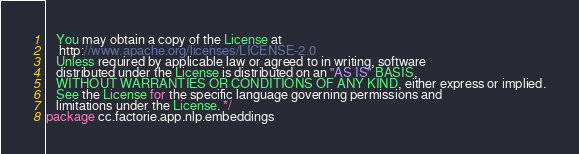Convert code to text. <code><loc_0><loc_0><loc_500><loc_500><_Scala_>   You may obtain a copy of the License at
    http://www.apache.org/licenses/LICENSE-2.0
   Unless required by applicable law or agreed to in writing, software
   distributed under the License is distributed on an "AS IS" BASIS,
   WITHOUT WARRANTIES OR CONDITIONS OF ANY KIND, either express or implied.
   See the License for the specific language governing permissions and
   limitations under the License. */
package cc.factorie.app.nlp.embeddings</code> 